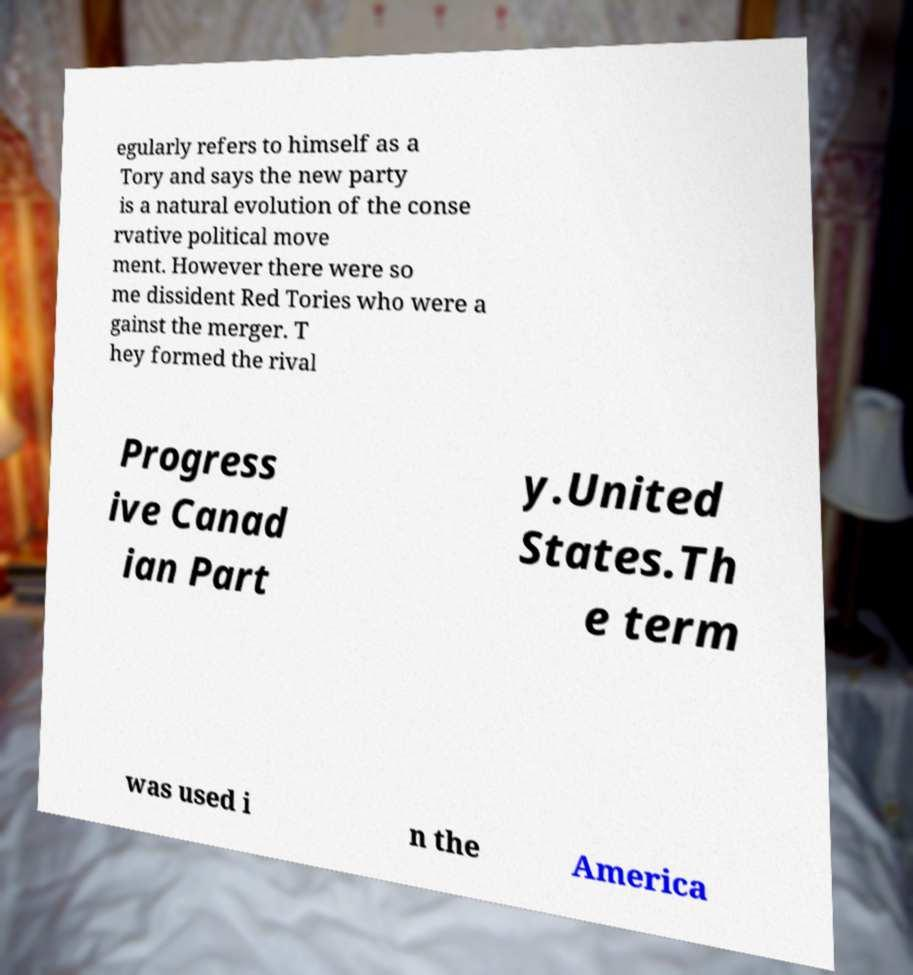I need the written content from this picture converted into text. Can you do that? egularly refers to himself as a Tory and says the new party is a natural evolution of the conse rvative political move ment. However there were so me dissident Red Tories who were a gainst the merger. T hey formed the rival Progress ive Canad ian Part y.United States.Th e term was used i n the America 